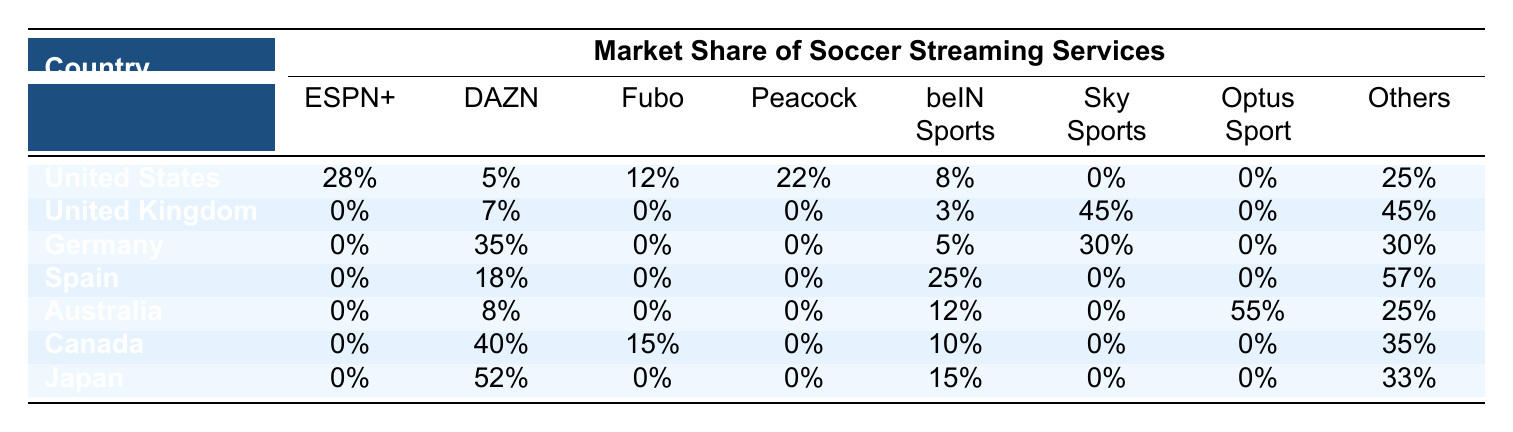What percentage of the market share does DAZN have in Japan? From the table, we can directly locate the row for Japan and see that DAZN has a market share of 52%.
Answer: 52% Which streaming service has the highest market share in the United Kingdom? Looking at the United Kingdom row, Sky Sports has the highest market share at 45%.
Answer: Sky Sports What is the total market share of beIN Sports across all countries? To find this, we sum the market shares of beIN Sports from each country: 8 + 3 + 5 + 25 + 12 + 10 + 15 = 78%.
Answer: 78% Is there any country where ESPN+ has a market share greater than 15%? From the table, we check the percentage for ESPN+ in each country and find that it is only 28% in the United States; therefore, the answer is yes.
Answer: Yes Which service has a larger market share in Germany: DAZN or Sky Sports? In the Germany row, DAZN has a market share of 35% while Sky Sports has 30%. Since 35% is greater than 30%, DAZN has the larger share.
Answer: DAZN What is the average market share of Fubo across all countries listed? To calculate the average, we first gather the Fubo percentages: 12%, 0%, 0%, 0%, 0%, 15%, 0% giving us values of 12 + 0 + 0 + 0 + 0 + 15 + 0 = 27%. There are 7 countries, so the average is 27% / 7 = approximately 3.86%.
Answer: 3.86% What percentage of the market share do the "Others" category represent in Australia? In the Australia row, the "Others" category has a market share of 25%.
Answer: 25% Which country has the highest total market share of "Others" and what is that percentage? Looking at the "Others" column across all rows, we see that Spain has the highest share at 57%.
Answer: Spain, 57% Is Peacock the only service with a market share in Canada? From the table, we can see several services listed in the Canada row: DAZN, Fubo, beIN Sports, and Others, among others. So the statement is false.
Answer: No 